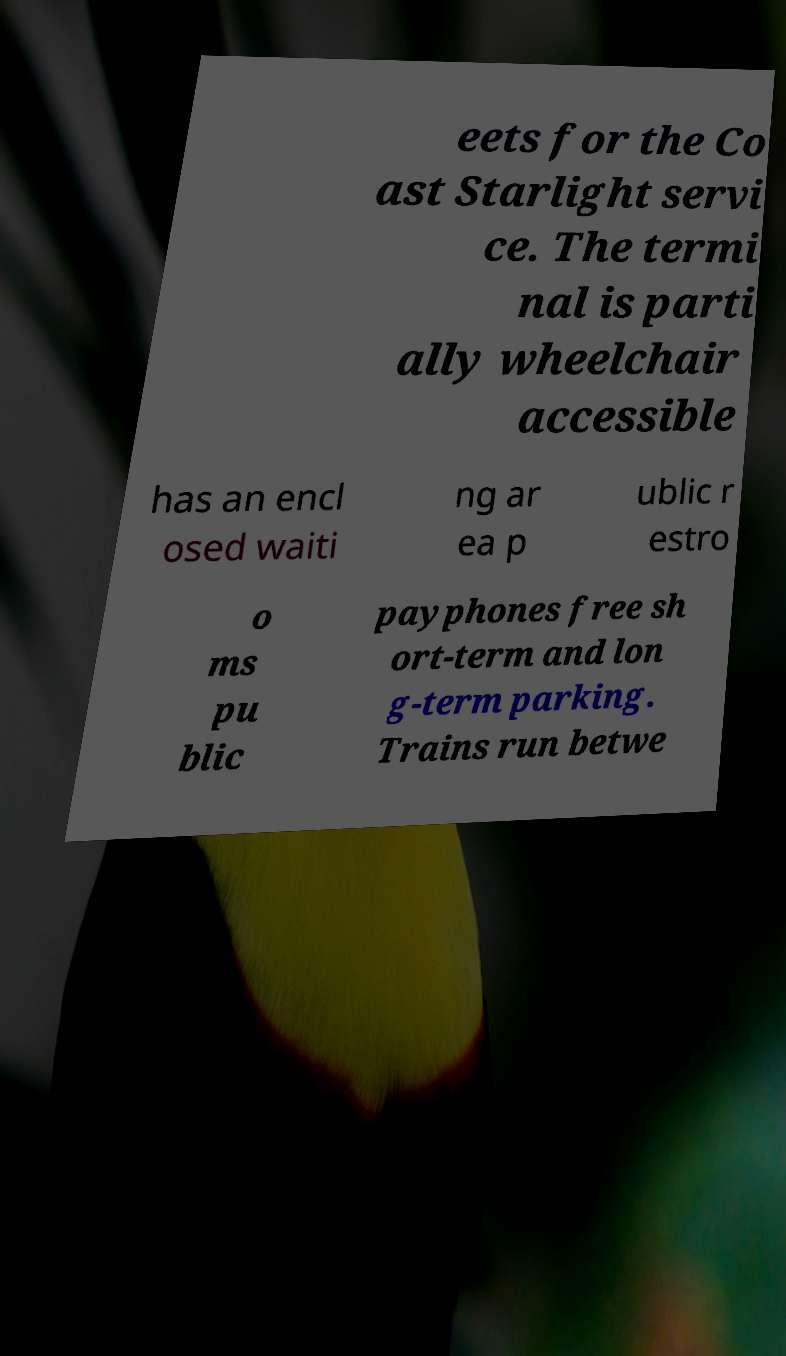I need the written content from this picture converted into text. Can you do that? eets for the Co ast Starlight servi ce. The termi nal is parti ally wheelchair accessible has an encl osed waiti ng ar ea p ublic r estro o ms pu blic payphones free sh ort-term and lon g-term parking. Trains run betwe 